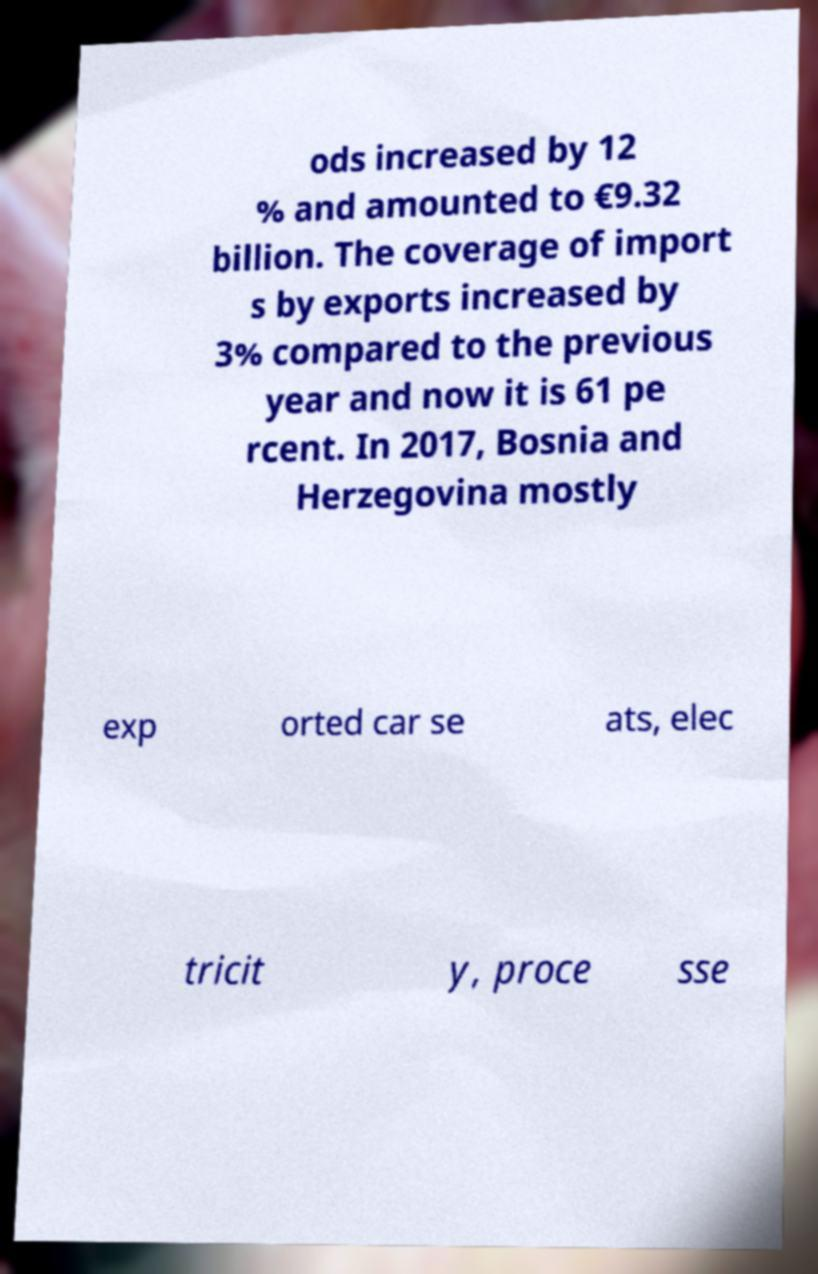There's text embedded in this image that I need extracted. Can you transcribe it verbatim? ods increased by 12 % and amounted to €9.32 billion. The coverage of import s by exports increased by 3% compared to the previous year and now it is 61 pe rcent. In 2017, Bosnia and Herzegovina mostly exp orted car se ats, elec tricit y, proce sse 